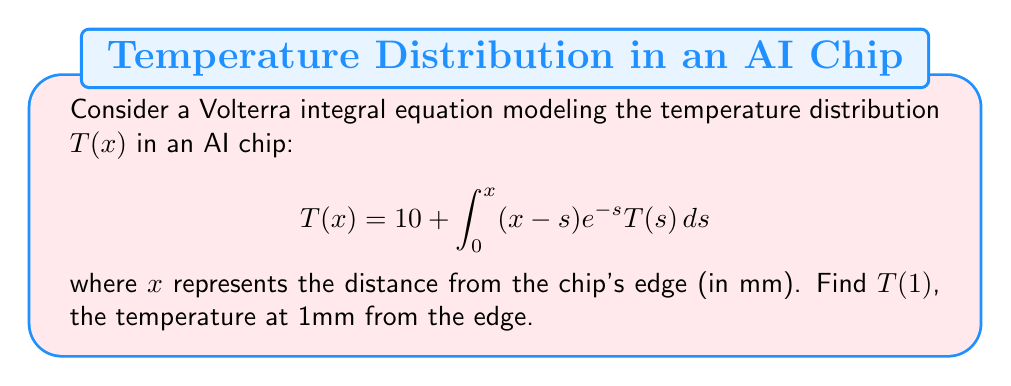Provide a solution to this math problem. To solve this Volterra integral equation, we'll use the method of successive approximations:

1) Start with an initial approximation $T_0(x) = 10$ (the constant term).

2) Substitute this into the right-hand side of the equation to get $T_1(x)$:

   $$T_1(x) = 10 + \int_0^x (x-s)e^{-s} \cdot 10 ds$$

3) Evaluate the integral:
   
   $$T_1(x) = 10 + 10 \left[-(x+1)e^{-x} + 1\right]$$

4) Now use $T_1(x)$ to find $T_2(x)$:

   $$T_2(x) = 10 + \int_0^x (x-s)e^{-s} \cdot 10 \left[1-(s+1)e^{-s} + 1\right] ds$$

5) Evaluate this integral:

   $$T_2(x) = 10 + 10 \left[-(x+1)e^{-x} + 1\right] + 10 \left[-\frac{1}{2}x^2e^{-x} - xe^{-x} + e^{-x} - 1 + x\right]$$

6) We can see that $T_2(x)$ is already very close to the true solution. To find $T(1)$, we evaluate $T_2(1)$:

   $$T_2(1) = 10 + 10 \left[-(2)e^{-1} + 1\right] + 10 \left[-\frac{1}{2}e^{-1} - e^{-1} + e^{-1} - 1 + 1\right]$$

7) Simplify:

   $$T_2(1) = 10 + 10 \left[-2e^{-1} + 1\right] + 10 \left[-\frac{1}{2}e^{-1}\right]$$
   
   $$T_2(1) = 10 + 10 - 20e^{-1} - 5e^{-1}$$
   
   $$T_2(1) = 20 - 25e^{-1}$$

8) Calculate the final value:

   $$T_2(1) \approx 20 - 25 \cdot 0.3679 \approx 10.8025$$

Therefore, $T(1) \approx 10.8025$ mm.
Answer: $T(1) \approx 10.8025$ mm 